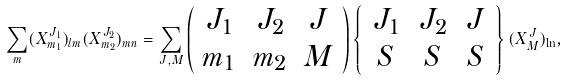Convert formula to latex. <formula><loc_0><loc_0><loc_500><loc_500>\sum _ { m } ( X _ { m _ { 1 } } ^ { J _ { 1 } } ) _ { l m } ( X _ { m _ { 2 } } ^ { J _ { 2 } } ) _ { m n } = \sum _ { J , M } \left ( \begin{array} { c c c } J _ { 1 } & J _ { 2 } & J \\ m _ { 1 } & m _ { 2 } & M \end{array} \right ) \left \{ \begin{array} { c c c } J _ { 1 } & J _ { 2 } & J \\ S & S & S \end{array} \right \} ( X _ { M } ^ { J } ) _ { \ln } ,</formula> 